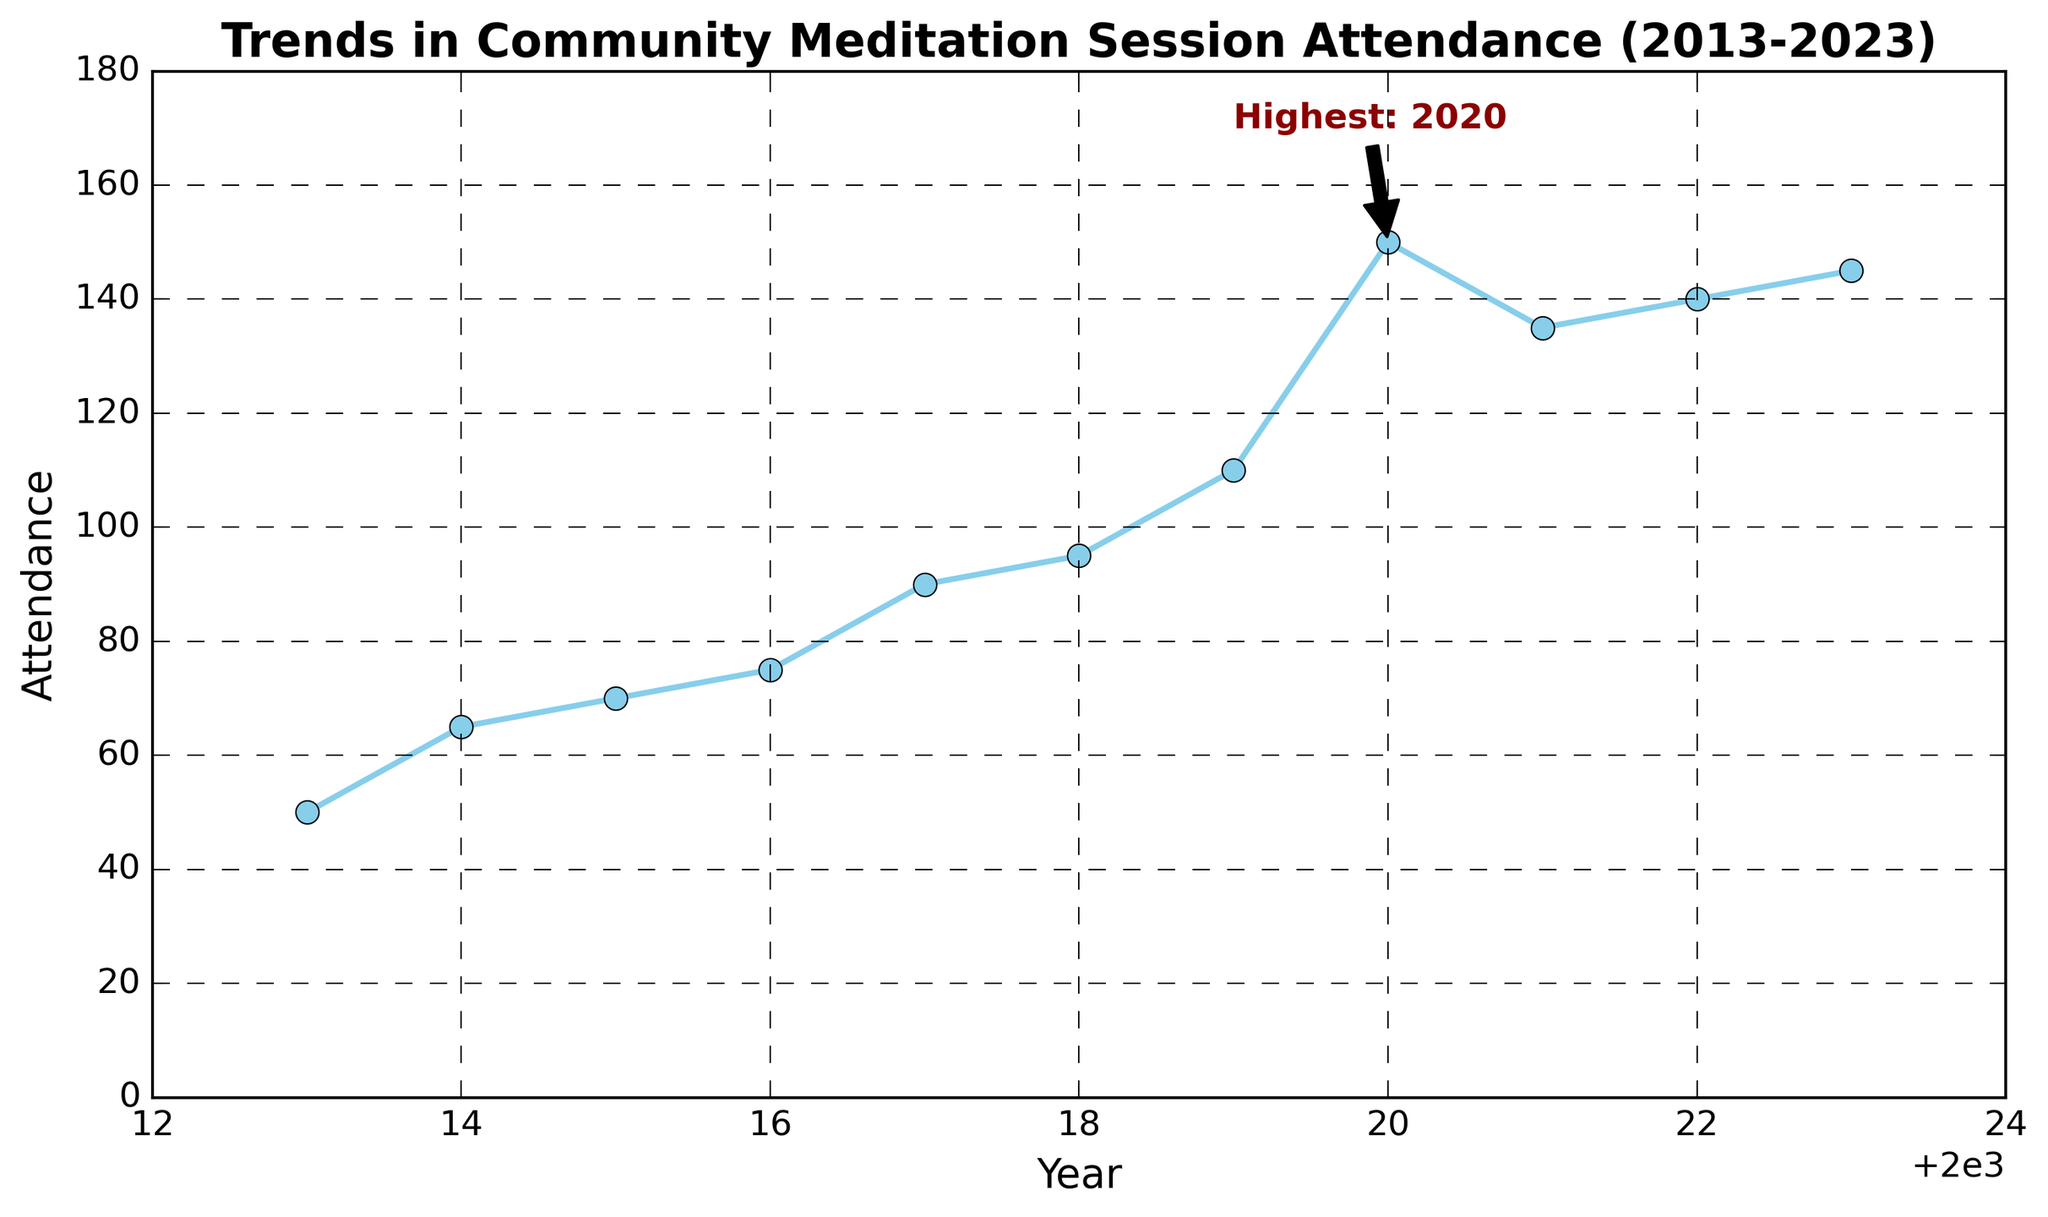What year saw the highest participation in community meditation sessions? The highest participation is marked by an annotation. It shows that the year with the highest attendance was 2020.
Answer: 2020 How did attendance change from 2019 to 2020? In 2019, attendance was 110, and in 2020, it increased to 150. Calculating the change: 150 - 110 = 40.
Answer: Increased by 40 What is the overall trend in attendance from 2013 to 2023? By observing the plot, we see an overall upward trend with attendance increasing year by year.
Answer: Increasing trend What is the difference in attendance between the years 2018 and 2021? Attendance in 2018 was 95, and in 2021, it was 135. The difference is: 135 - 95 = 40.
Answer: 40 Which years observed the greatest drop in attendance? The greatest drop in attendance occurred between 2020 (150) and 2021 (135). Calculating the drop: 150 - 135 = 15.
Answer: 2020 to 2021 In which year did the attendance first exceed 100 participants? Check the year before and the year that attendance first exceeds 100. In 2018, it was 95, and in 2019, it was 110, so 2019.
Answer: 2019 What was the average attendance from 2013 to 2023? Sum all attendance values and divide by the number of years: (50+65+70+75+90+95+110+150+135+140+145)/11 = 1025/11 ≈ 93.18.
Answer: ≈ 93.18 Between which two consecutive years was the increase in attendance the highest? Comparing year-on-year increases, the jump between 2019 (110) and 2020 (150) is the largest: 150 - 110 = 40.
Answer: 2019 to 2020 How did attendance in 2023 compare to 2022? The attendance in 2022 was 140 and in 2023 it was 145. Comparing both: 145 - 140 = 5.
Answer: Increased by 5 Which year had an attendance closest to 100? Comparing all years, attendance in 2019 was 110, which is closest to 100.
Answer: 2019 